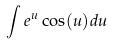Convert formula to latex. <formula><loc_0><loc_0><loc_500><loc_500>\int e ^ { u } \cos ( u ) d u</formula> 